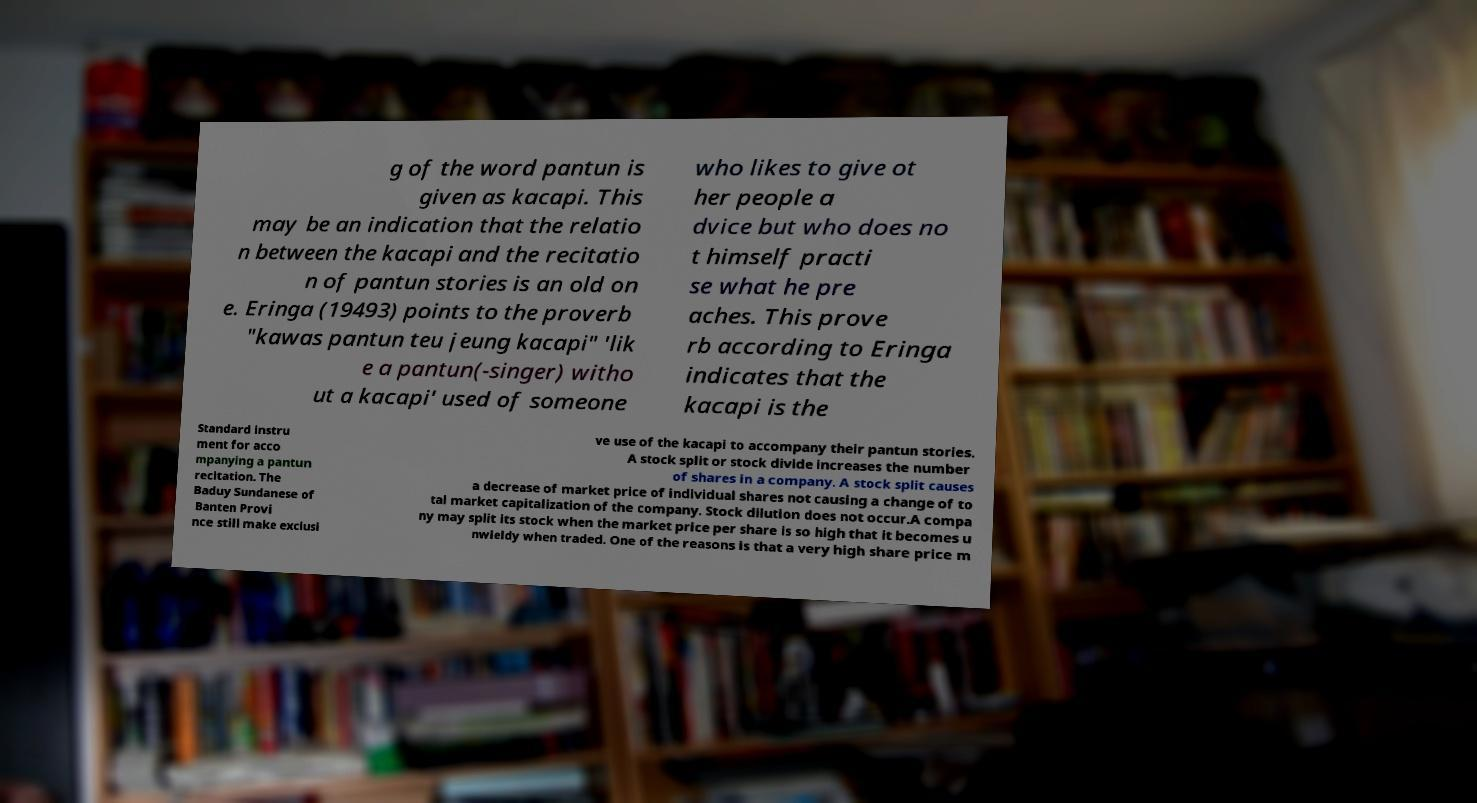What messages or text are displayed in this image? I need them in a readable, typed format. g of the word pantun is given as kacapi. This may be an indication that the relatio n between the kacapi and the recitatio n of pantun stories is an old on e. Eringa (19493) points to the proverb "kawas pantun teu jeung kacapi" 'lik e a pantun(-singer) witho ut a kacapi' used of someone who likes to give ot her people a dvice but who does no t himself practi se what he pre aches. This prove rb according to Eringa indicates that the kacapi is the Standard instru ment for acco mpanying a pantun recitation. The Baduy Sundanese of Banten Provi nce still make exclusi ve use of the kacapi to accompany their pantun stories. A stock split or stock divide increases the number of shares in a company. A stock split causes a decrease of market price of individual shares not causing a change of to tal market capitalization of the company. Stock dilution does not occur.A compa ny may split its stock when the market price per share is so high that it becomes u nwieldy when traded. One of the reasons is that a very high share price m 